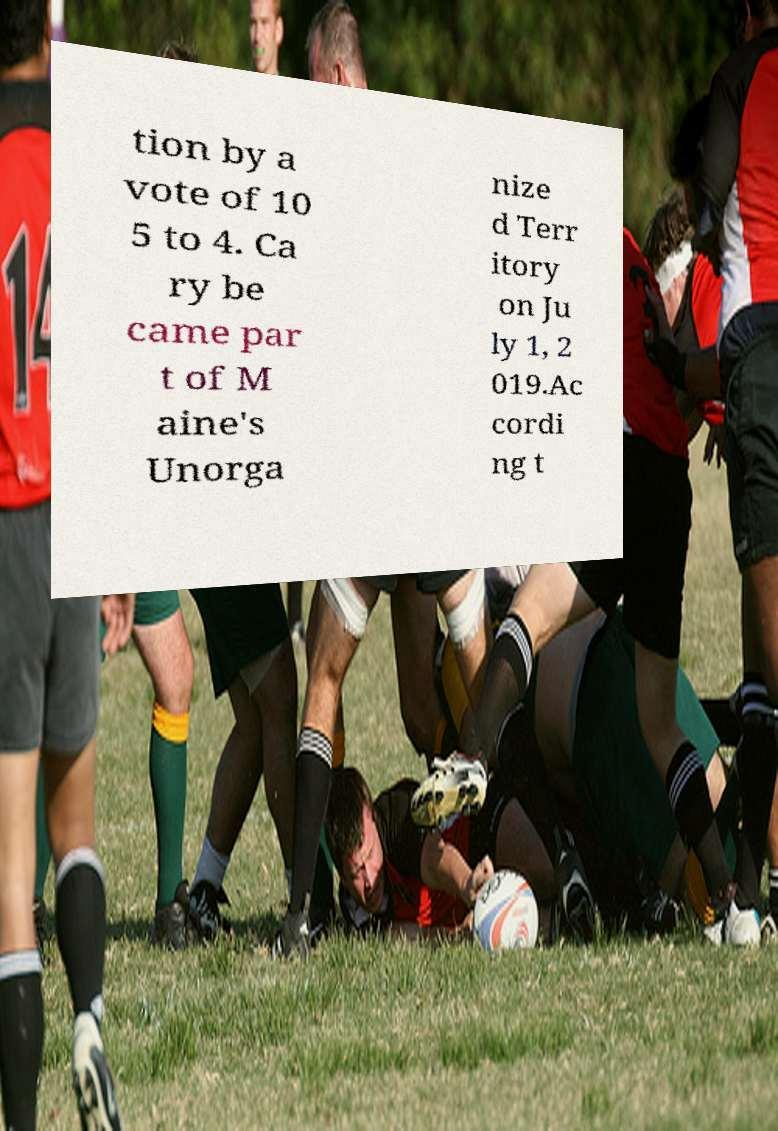Could you assist in decoding the text presented in this image and type it out clearly? tion by a vote of 10 5 to 4. Ca ry be came par t of M aine's Unorga nize d Terr itory on Ju ly 1, 2 019.Ac cordi ng t 